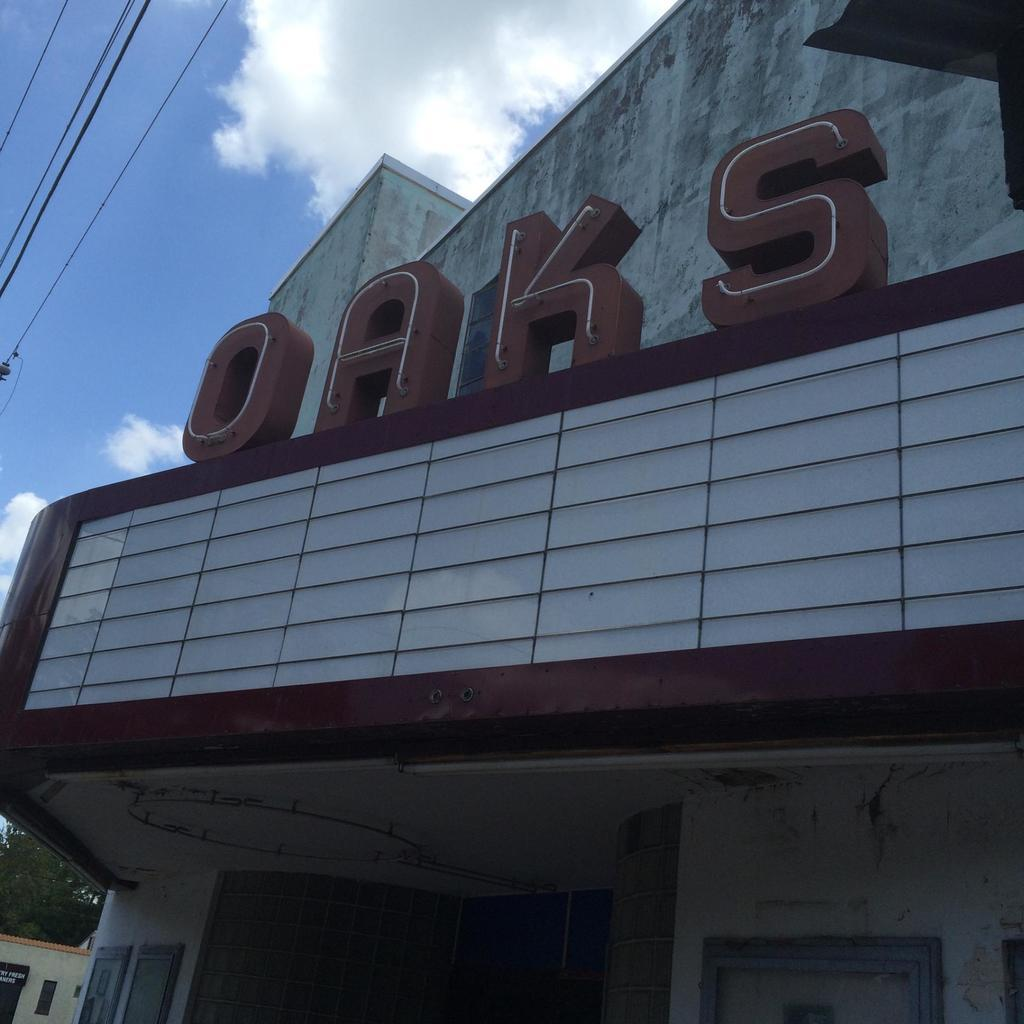What type of structures can be seen in the image? There are houses in the image. What is written or displayed on a wall in the image? There is text on a wall in the image. What else can be seen in the image besides houses and text? There are wires and trees visible in the image. What is visible in the background of the image? The sky is visible in the image. What type of hair can be seen on the houses in the image? There is no hair present on the houses in the image; they are inanimate structures. 